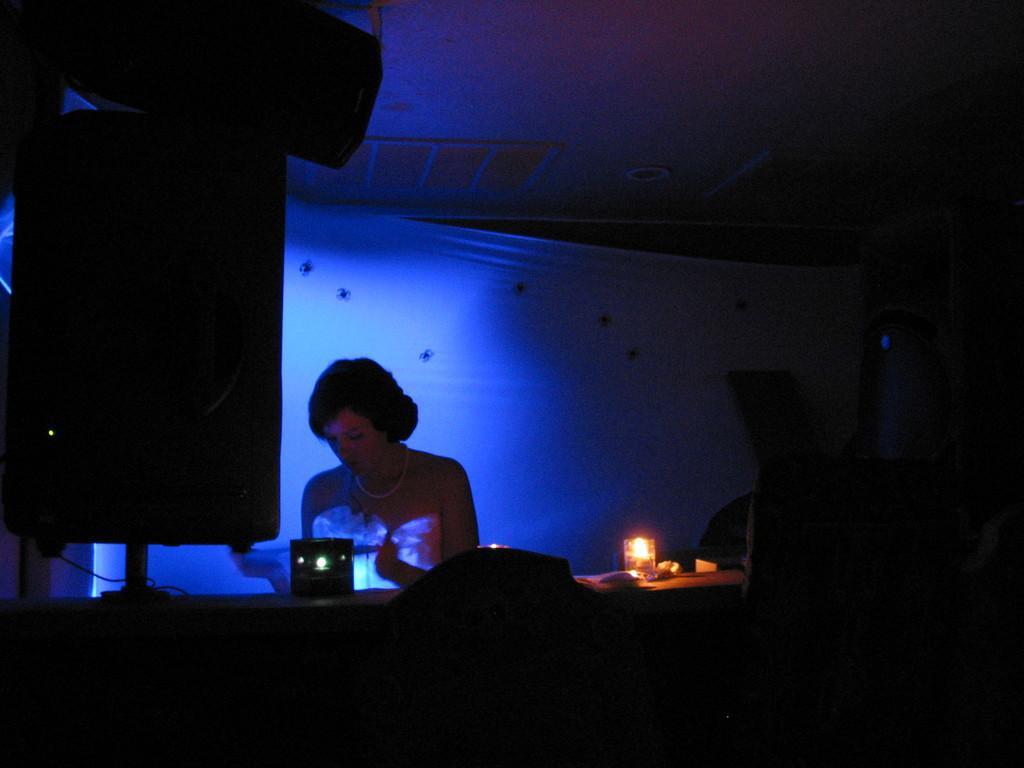Describe this image in one or two sentences. In the foreground of this picture, there is a woman standing in front of a table like structure on which candle like an object is placed on it. On the left, there is speaker box. In the front, there are chairs like objects. In the background, there is a curtain and a blue light. On the top, there is a ceiling. 